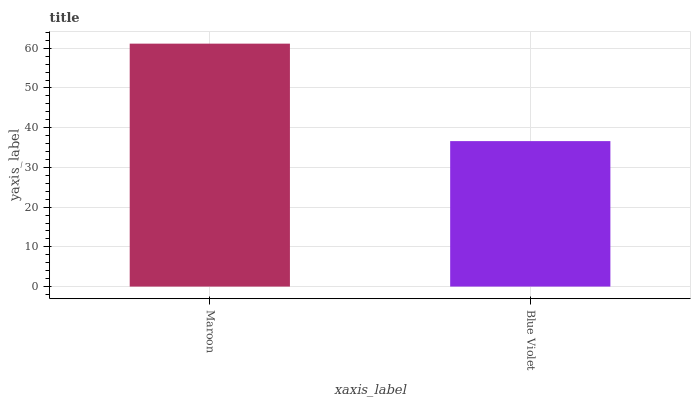Is Blue Violet the minimum?
Answer yes or no. Yes. Is Maroon the maximum?
Answer yes or no. Yes. Is Blue Violet the maximum?
Answer yes or no. No. Is Maroon greater than Blue Violet?
Answer yes or no. Yes. Is Blue Violet less than Maroon?
Answer yes or no. Yes. Is Blue Violet greater than Maroon?
Answer yes or no. No. Is Maroon less than Blue Violet?
Answer yes or no. No. Is Maroon the high median?
Answer yes or no. Yes. Is Blue Violet the low median?
Answer yes or no. Yes. Is Blue Violet the high median?
Answer yes or no. No. Is Maroon the low median?
Answer yes or no. No. 